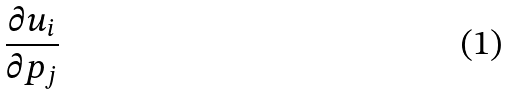Convert formula to latex. <formula><loc_0><loc_0><loc_500><loc_500>\frac { \partial u _ { i } } { \partial p _ { j } }</formula> 